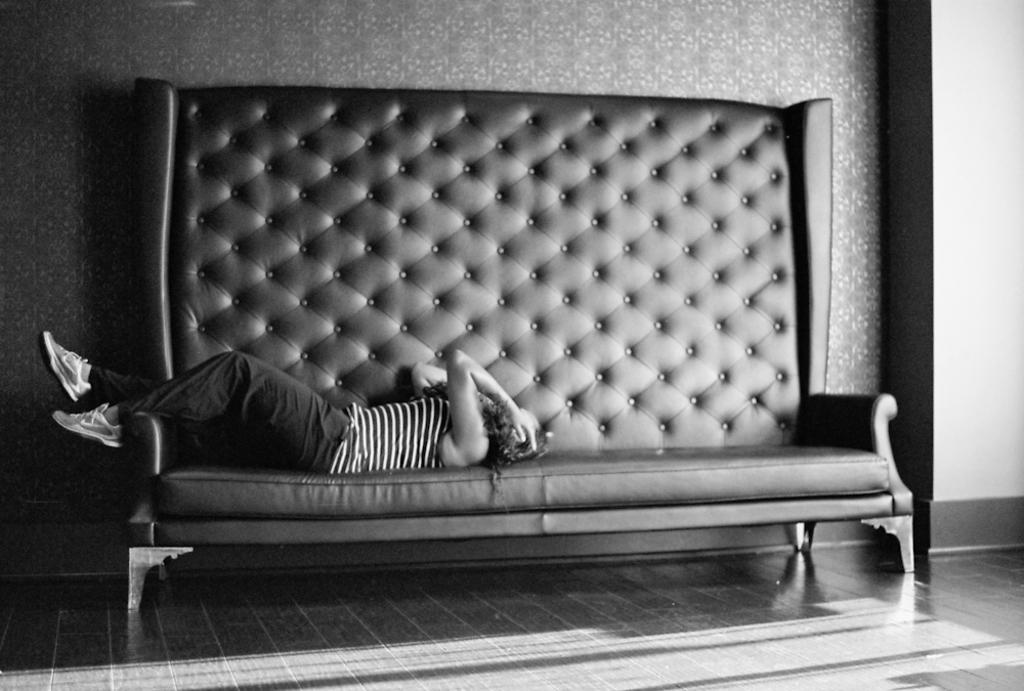What is the person in the image doing? The person is laying on a sofa. What can be seen in the background of the image? There is a wall in the background of the image. What part of the room is visible in the image? The floor is visible in the image. What type of bead is being used to extinguish the fire in the image? There is no fire or bead present in the image. What kind of fruit is being eaten by the person on the sofa in the image? There is no fruit visible in the image; the person is laying on a sofa with no food present. 